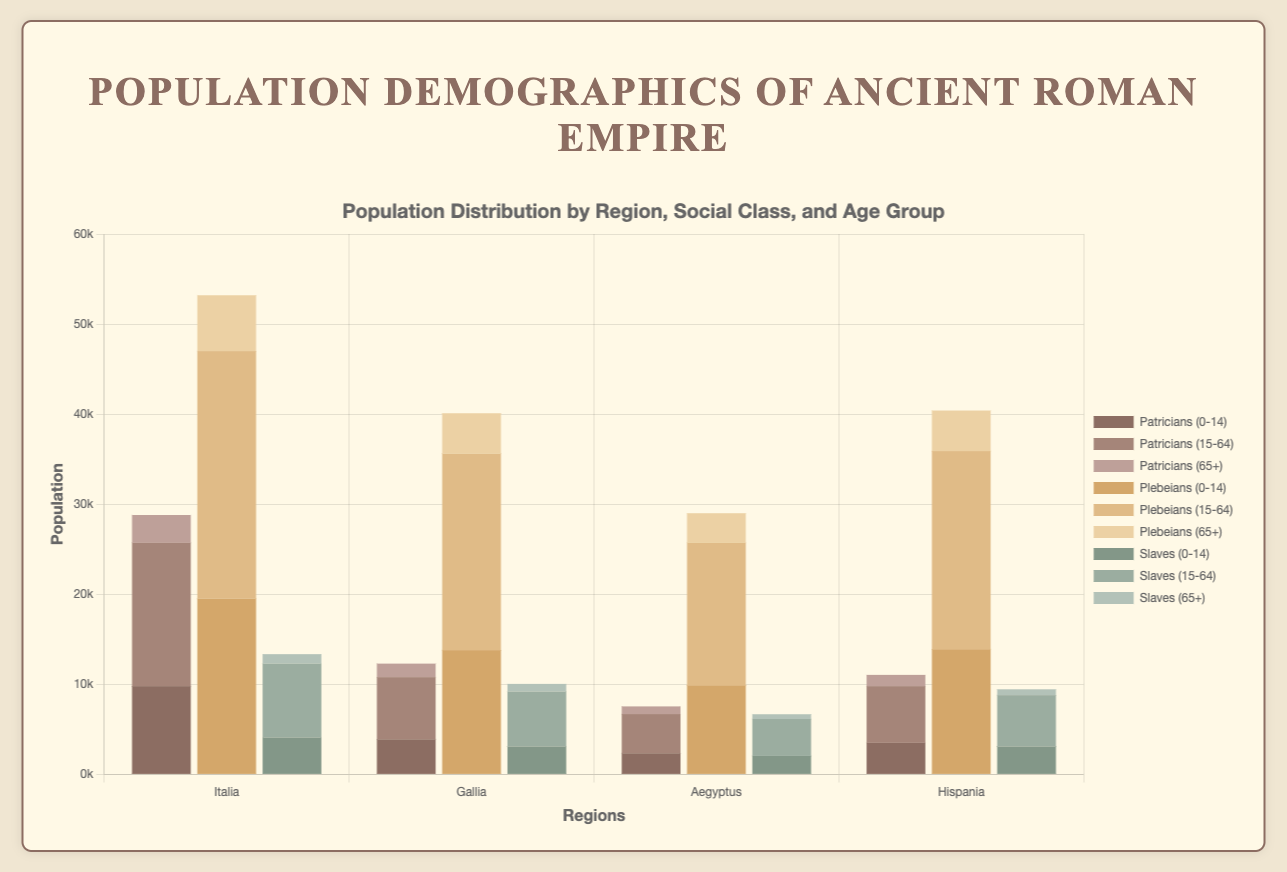Which region has the highest population of Patricians aged 15-64? To find the region with the highest population of Patricians aged 15-64, look at the height of the bars labeled corresponding to this demographic in different regions. Summing males and females in each region: Italia (15900), Gallia (6900), Aegyptus (4350), Hispania (6300). The highest is in Italia
Answer: Italia What is the total population of Slaves in the 0-14 age group across all regions? Sum the populations of Slaves aged 0-14 from each region: Italia (4100), Gallia (3100), Aegyptus (2050), Hispania (3100). The total is 4100 + 3100 + 2050 + 3100
Answer: 12350 Which age group has the smallest population in Hispania? Compare the heights representing each age group across all social classes in Hispania. Age groups in order of total populace: 0-14 (10400), 15-64 (16800), 65+ (3850). The smallest is 65+
Answer: 65+ Are there more males or females in Gallia's Patrician class aged 65+? Compare the male and female portions for Gallia's Patricians aged 65+: Males (700), Females (800). The greater number is Female
Answer: Females Which social class has the largest proportion of the population in Aegyptus? Sum the total populations of the Patricians, Plebeians, and Slaves for Aegyptus: Patricians (4100), Plebeians (24400), Slaves (5400). The largest sum is for Plebeians
Answer: Plebeians How does Italica’s population of Plebeians aged 0-14 compare to those aged 15-64? Compare the height of the Plebeians aged 0-14 and 15-64 for both males and females in Italica: 0-14 (19500), 15-64 (27500). 27500 is larger
Answer: 15-64 is larger What is the average population of Patricians aged 0-14 in the four regions? Sum the population of Patricians aged 0-14 in all regions and divide by the number of regions: (9800 + 3900 + 2350 + 3500) / 4 = 19550 / 4 = 4887.5
Answer: 4887.5 Which region has the smallest total slave population? Sum the slave populations for each region: Italia (13350), Gallia (10550), Aegyptus (5350), Hispania (7500). The smallest is Aegyptus
Answer: Aegyptus 